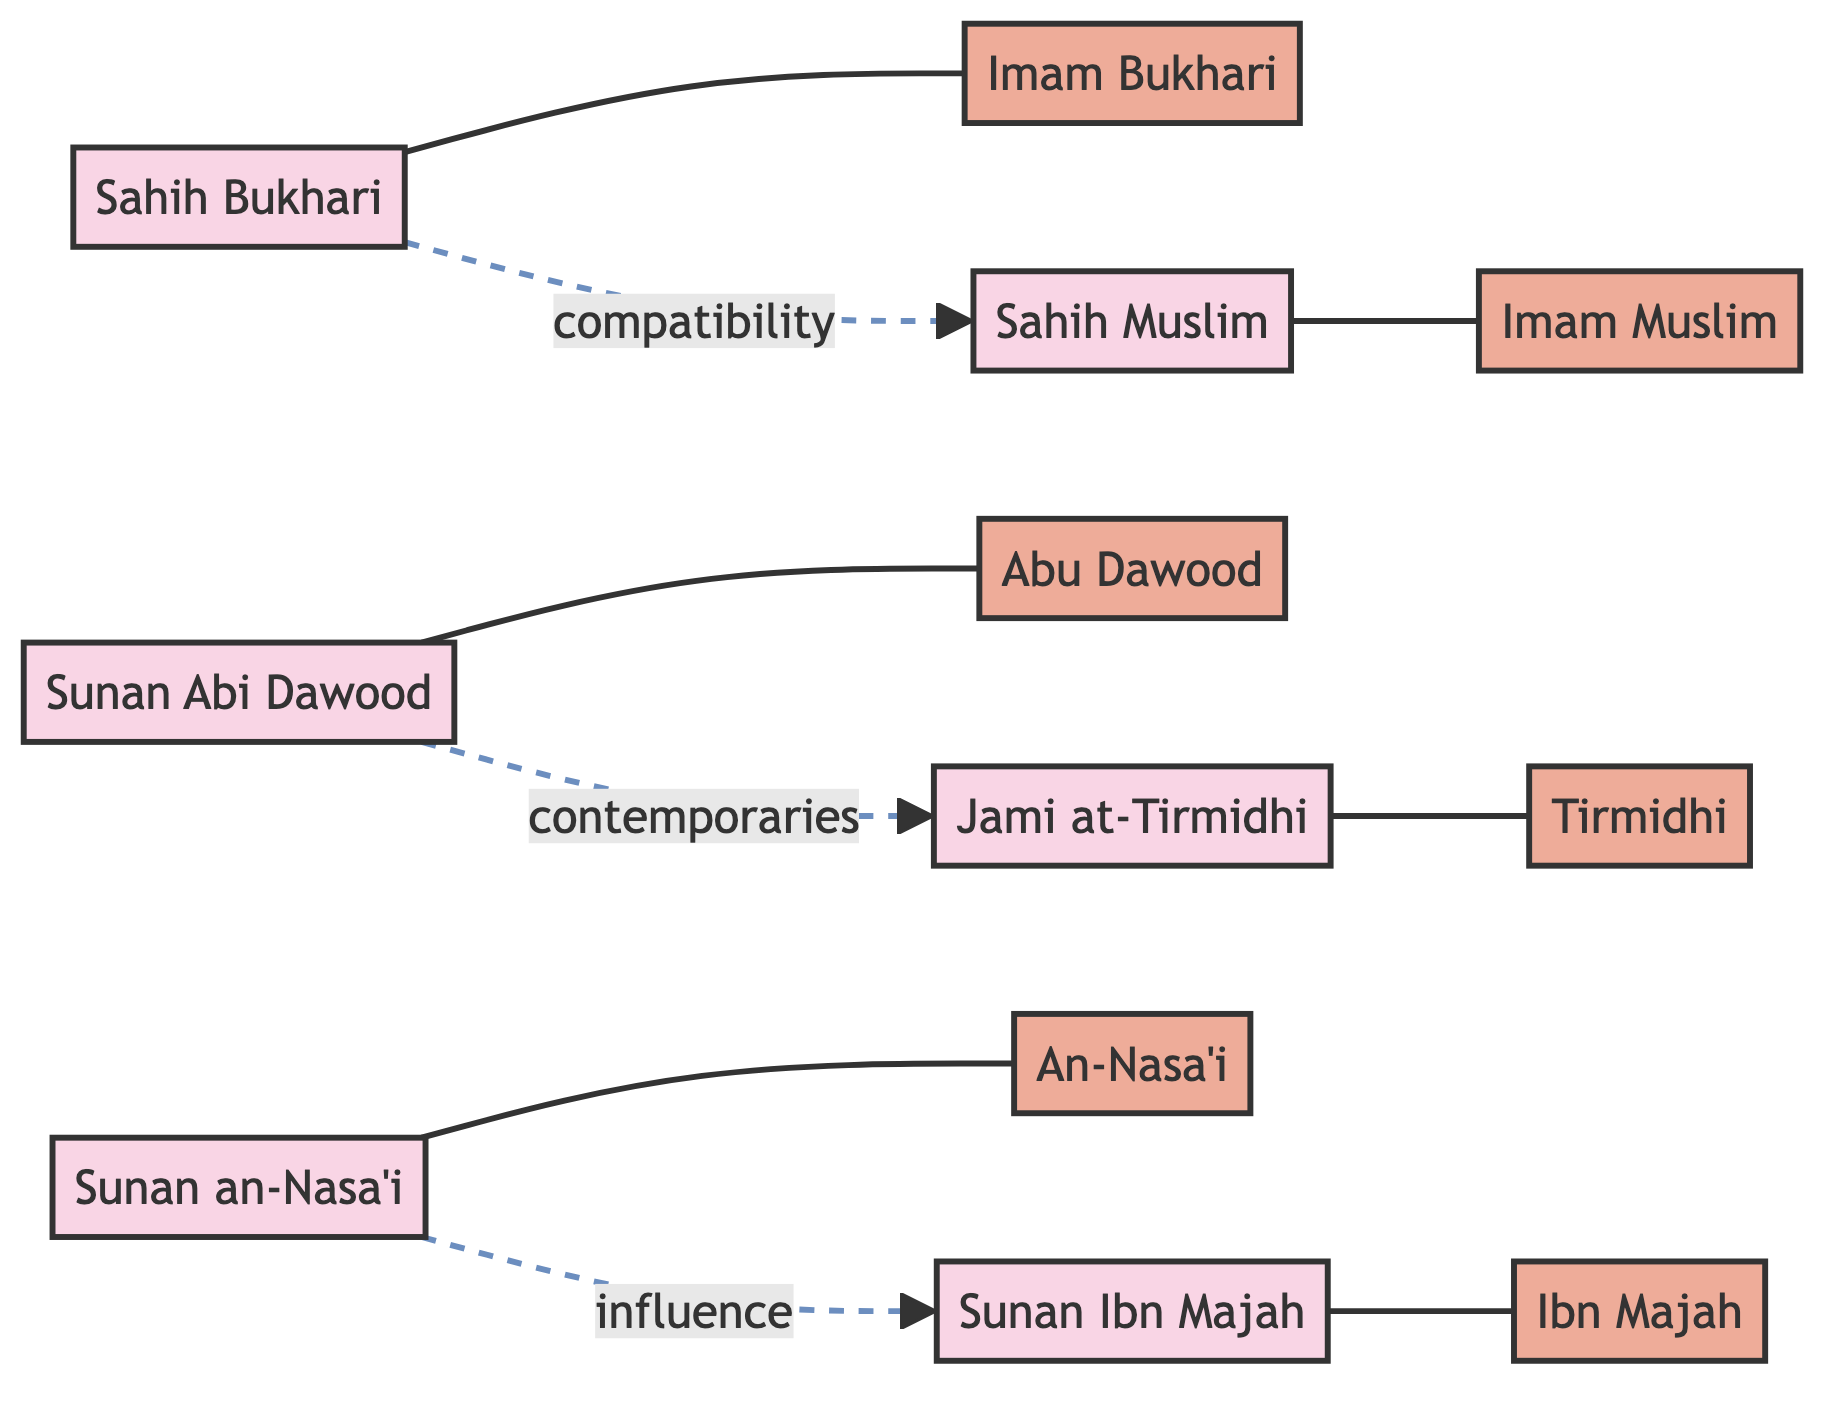What are the total number of nodes in the diagram? The diagram contains 12 nodes: "Sahih Bukhari", "Sahih Muslim", "Sunan Abi Dawood", "Jami at-Tirmidhi", "Sunan an-Nasa'i", "Sunan Ibn Majah", "Imam Bukhari", "Imam Muslim", "Abu Dawood", "Tirmidhi", "An-Nasa'i", and "Ibn Majah".
Answer: 12 Who compiled Sahih Muslim? The edge connecting "Sahih Muslim" to "Imam Muslim" indicates that Imam Muslim is the compiler of Sahih Muslim.
Answer: Imam Muslim What is the relationship between Sahih Bukhari and Sahih Muslim? The diagram shows a dashed line labeled "compatibility" between "Sahih Bukhari" and "Sahih Muslim", indicating a specific relationship.
Answer: compatibility How many edges are present in the diagram? There are 8 edges indicating relationships between nodes: 6 representing direct compiler relationships and 3 representing specific relationships like compatibility, contemporaries, and influence.
Answer: 8 Which hadith collection is associated with Abu Dawood as its compiler? The diagram shows an edge from "Sunan Abi Dawood" to "Abu Dawood", indicating that Abu Dawood is the compiler of this collection.
Answer: Sunan Abi Dawood Which two collections are noted as contemporaries in the diagram? The dashed line between "Sunan Abi Dawood" and "Jami at-Tirmidhi" labeled "contemporaries" specifies the relationship between these two collections.
Answer: Sunan Abi Dawood and Jami at-Tirmidhi Is there any influence noted between Sunan an-Nasa'i and Sunan Ibn Majah? The diagram illustrates an influence relationship between "Sunan an-Nasa'i" and "Sunan Ibn Majah", shown by a dashed line connecting the two with the label "influence".
Answer: Yes What type of relationship is depicted between Sahih Bukhari and Imam Bukhari? The relationship is depicted with a solid line which is a direct connection indicating that "Imam Bukhari" is the compiler of "Sahih Bukhari".
Answer: Direct connection 